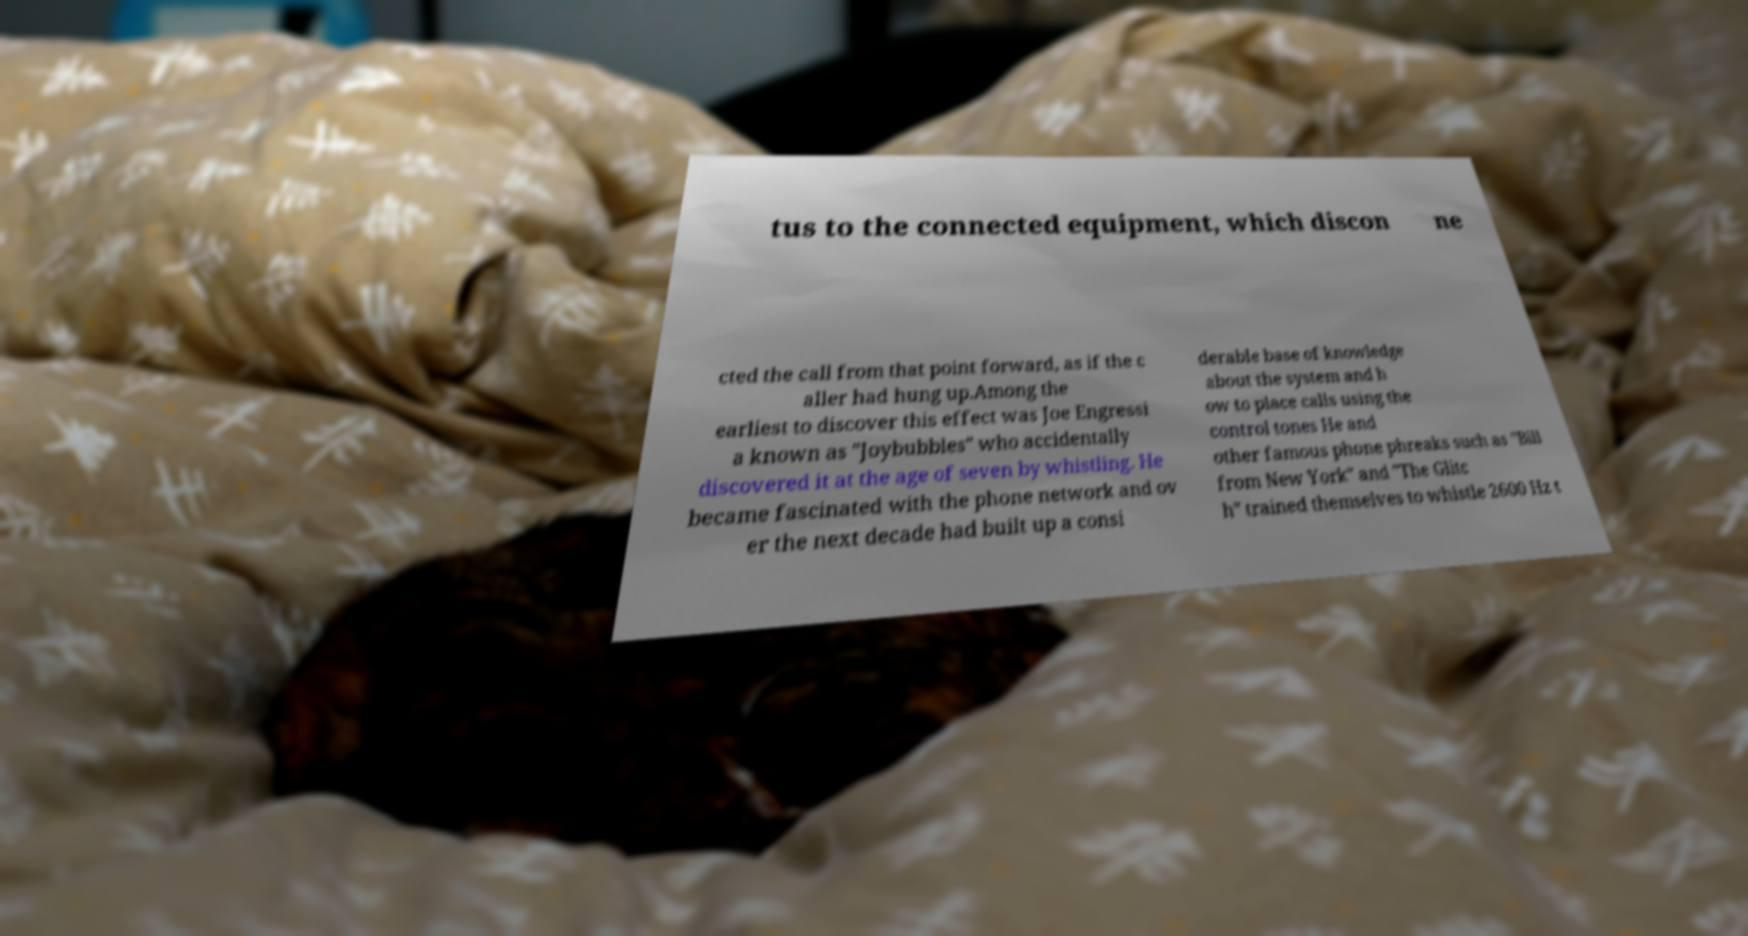Could you assist in decoding the text presented in this image and type it out clearly? tus to the connected equipment, which discon ne cted the call from that point forward, as if the c aller had hung up.Among the earliest to discover this effect was Joe Engressi a known as "Joybubbles" who accidentally discovered it at the age of seven by whistling. He became fascinated with the phone network and ov er the next decade had built up a consi derable base of knowledge about the system and h ow to place calls using the control tones He and other famous phone phreaks such as "Bill from New York" and "The Glitc h" trained themselves to whistle 2600 Hz t 